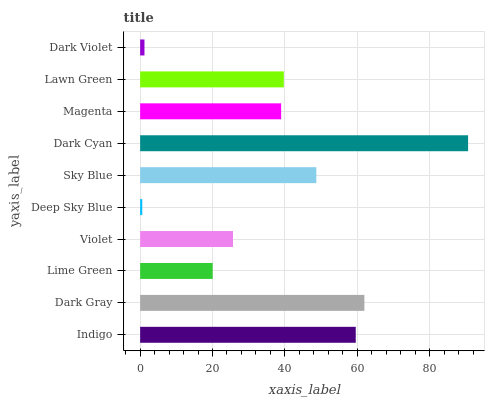Is Deep Sky Blue the minimum?
Answer yes or no. Yes. Is Dark Cyan the maximum?
Answer yes or no. Yes. Is Dark Gray the minimum?
Answer yes or no. No. Is Dark Gray the maximum?
Answer yes or no. No. Is Dark Gray greater than Indigo?
Answer yes or no. Yes. Is Indigo less than Dark Gray?
Answer yes or no. Yes. Is Indigo greater than Dark Gray?
Answer yes or no. No. Is Dark Gray less than Indigo?
Answer yes or no. No. Is Lawn Green the high median?
Answer yes or no. Yes. Is Magenta the low median?
Answer yes or no. Yes. Is Violet the high median?
Answer yes or no. No. Is Deep Sky Blue the low median?
Answer yes or no. No. 